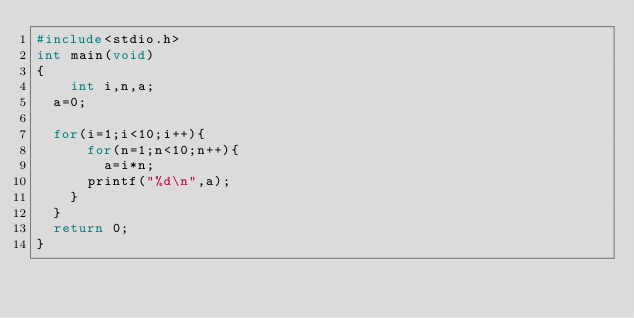<code> <loc_0><loc_0><loc_500><loc_500><_C++_>#include<stdio.h>
int main(void)
{
    int i,n,a;
	a=0;
	
	for(i=1;i<10;i++){
	    for(n=1;n<10;n++){
		    a=i*n;
			printf("%d\n",a);
		}
	}
	return 0;
}</code> 